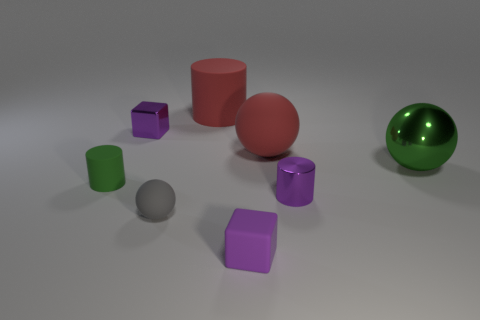What number of other objects are the same material as the tiny gray ball?
Provide a succinct answer. 4. Is the purple block that is in front of the small green rubber object made of the same material as the green thing that is on the left side of the metallic cylinder?
Your answer should be very brief. Yes. What number of purple metallic things are in front of the red rubber sphere and left of the purple matte thing?
Ensure brevity in your answer.  0. Are there any tiny things of the same shape as the big green shiny object?
Keep it short and to the point. Yes. What is the shape of the gray rubber object that is the same size as the green matte thing?
Provide a succinct answer. Sphere. Is the number of small rubber spheres in front of the matte block the same as the number of small cylinders to the right of the big matte sphere?
Provide a short and direct response. No. What size is the purple block behind the red rubber object that is on the right side of the tiny purple matte object?
Ensure brevity in your answer.  Small. Are there any purple spheres that have the same size as the red rubber sphere?
Your answer should be very brief. No. The other cylinder that is made of the same material as the large red cylinder is what color?
Give a very brief answer. Green. Are there fewer small purple metal cubes than red objects?
Ensure brevity in your answer.  Yes. 